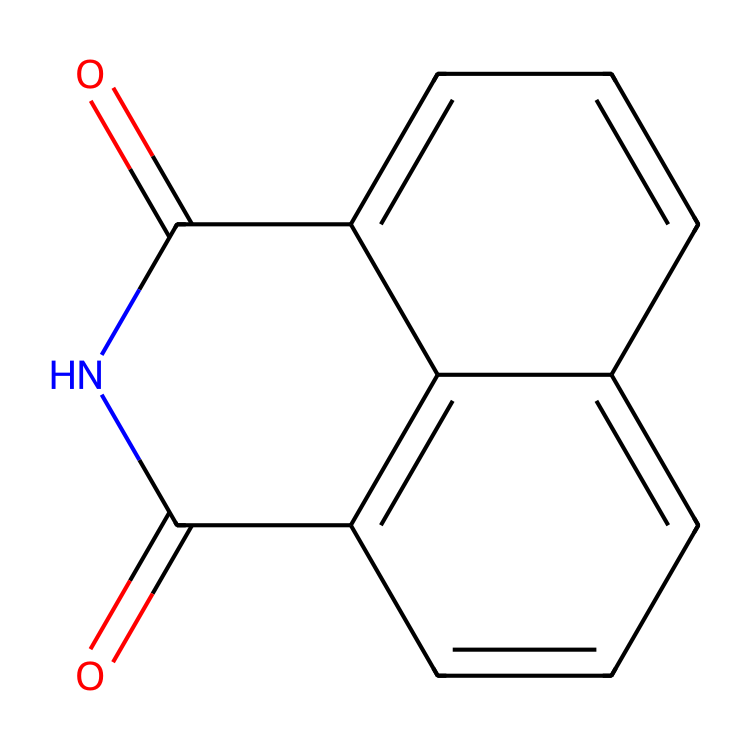How many nitrogen atoms are present in naphthalimide? By examining the structural representation, we can identify the nitrogen atoms. In the provided SMILES, there are two occurrences of "N," indicating the presence of two nitrogen atoms.
Answer: 2 What is the molecular formula of naphthalimide? By analyzing the structure, we account for the constituent elements: carbon, hydrogen, oxygen, and nitrogen. The resulting formula, based on the count from the structure, is C12H8N2O2.
Answer: C12H8N2O2 What type of functional groups are present in naphthalimide? The molecule contains imide functional groups, recognizable by the structure surrounding the nitrogen atoms and the carbonyl groups (C=O) attached to these nitrogen.
Answer: imide How many carbon atoms are in naphthalimide? Counting the carbon atoms observed in the structure, we find that there are twelve carbon atoms present in the molecule.
Answer: 12 What is the main application of naphthalimide in cookware? Naphthalimide is primarily used in food-safe coatings due to its chemical properties that enhance durability and resistance to heat and chemicals, making it suitable for cooking applications.
Answer: food-safe coatings What features make naphthalimide suitable for high-temperature applications? The presence of stable carbon and nitrogen bonds within its imide structure contributes to its thermal stability, enabling it to withstand high temperatures without decomposition.
Answer: thermal stability How does the structure of naphthalimide contribute to its solubility properties? The presence of polar carbonyl groups in the imide structure enhances its solubility in polar solvents while possibly maintaining reduced solubility in nonpolar solvents. Thus, it has a balanced solubility profile.
Answer: balanced solubility profile 